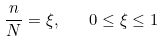Convert formula to latex. <formula><loc_0><loc_0><loc_500><loc_500>\frac { n } { N } = \xi , \quad 0 \leq \xi \leq 1</formula> 